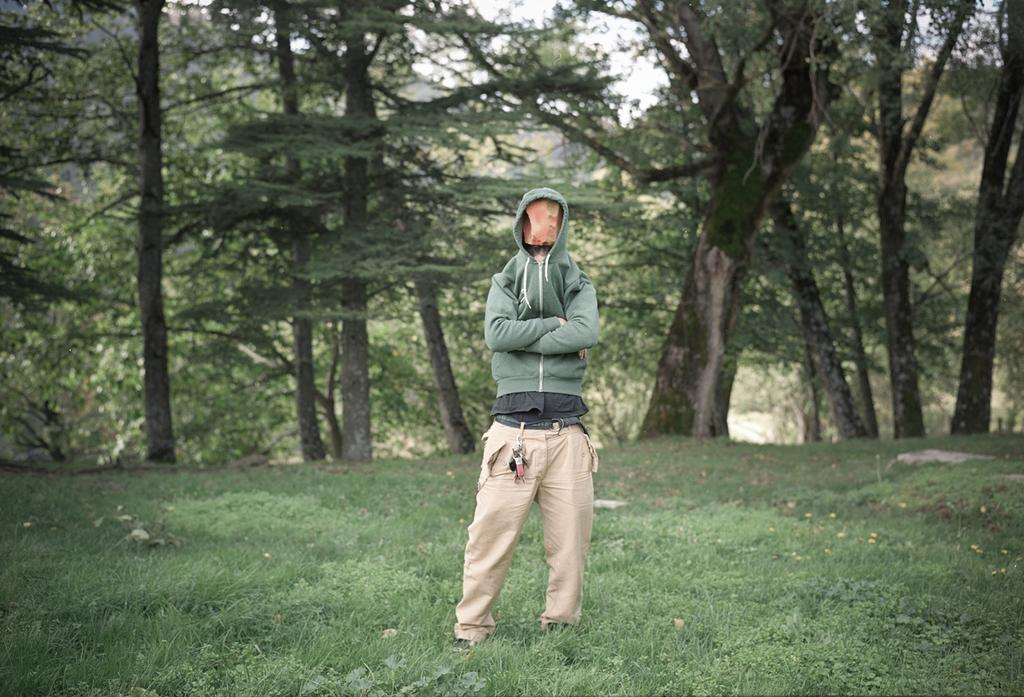What can be seen in the background of the image? There are trees in the background of the image. What is the person in the image wearing? The person is wearing a hoodie in the image. Can you describe the person's face in the image? The person's face is covered in the image. What type of surface is the person standing on? The person is standing on the grass in the image. Is the person playing a guitar in the image? There is no guitar present in the image. How many balls can be seen in the image? There are no balls visible in the image. 